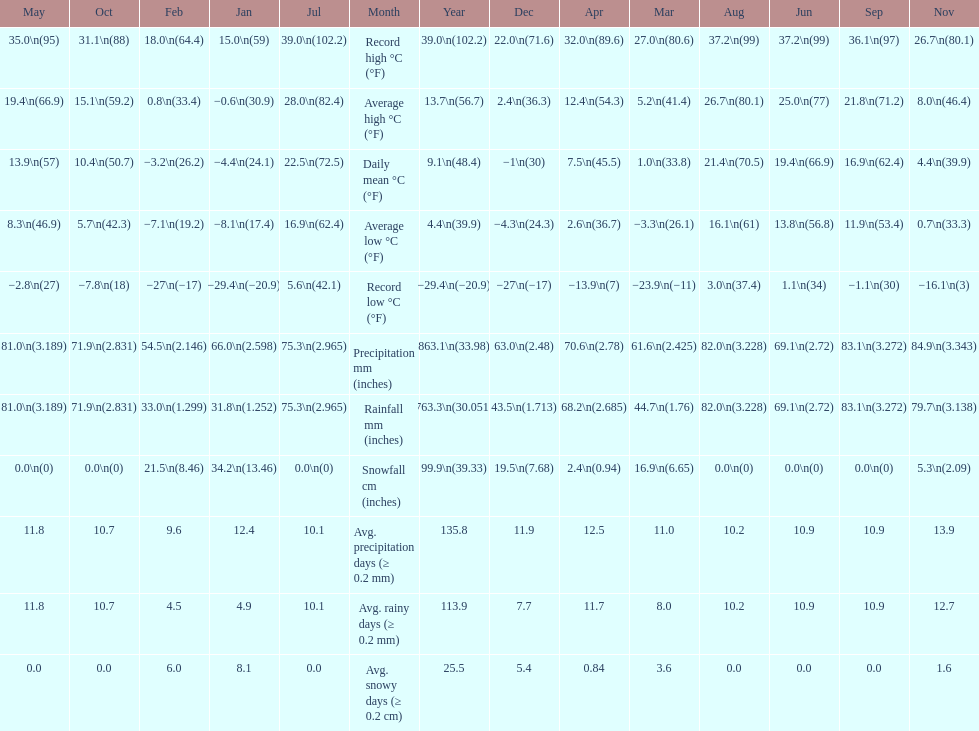Which month had an average high of 21.8 degrees and a record low of -1.1? September. 